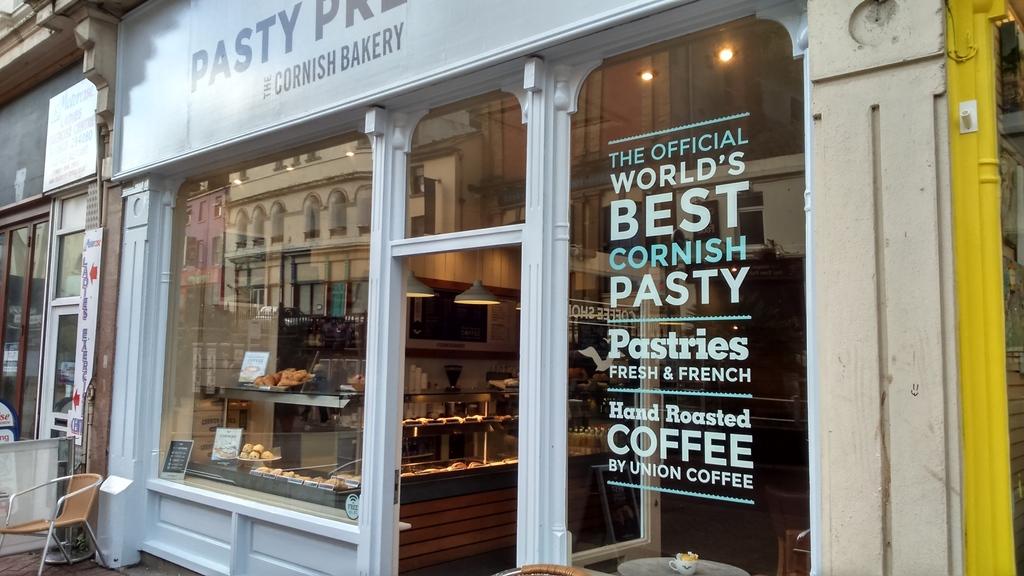What kind of beverage is sold here?
Make the answer very short. Coffee. What kind of pastry is sold?
Your response must be concise. Cornish. 